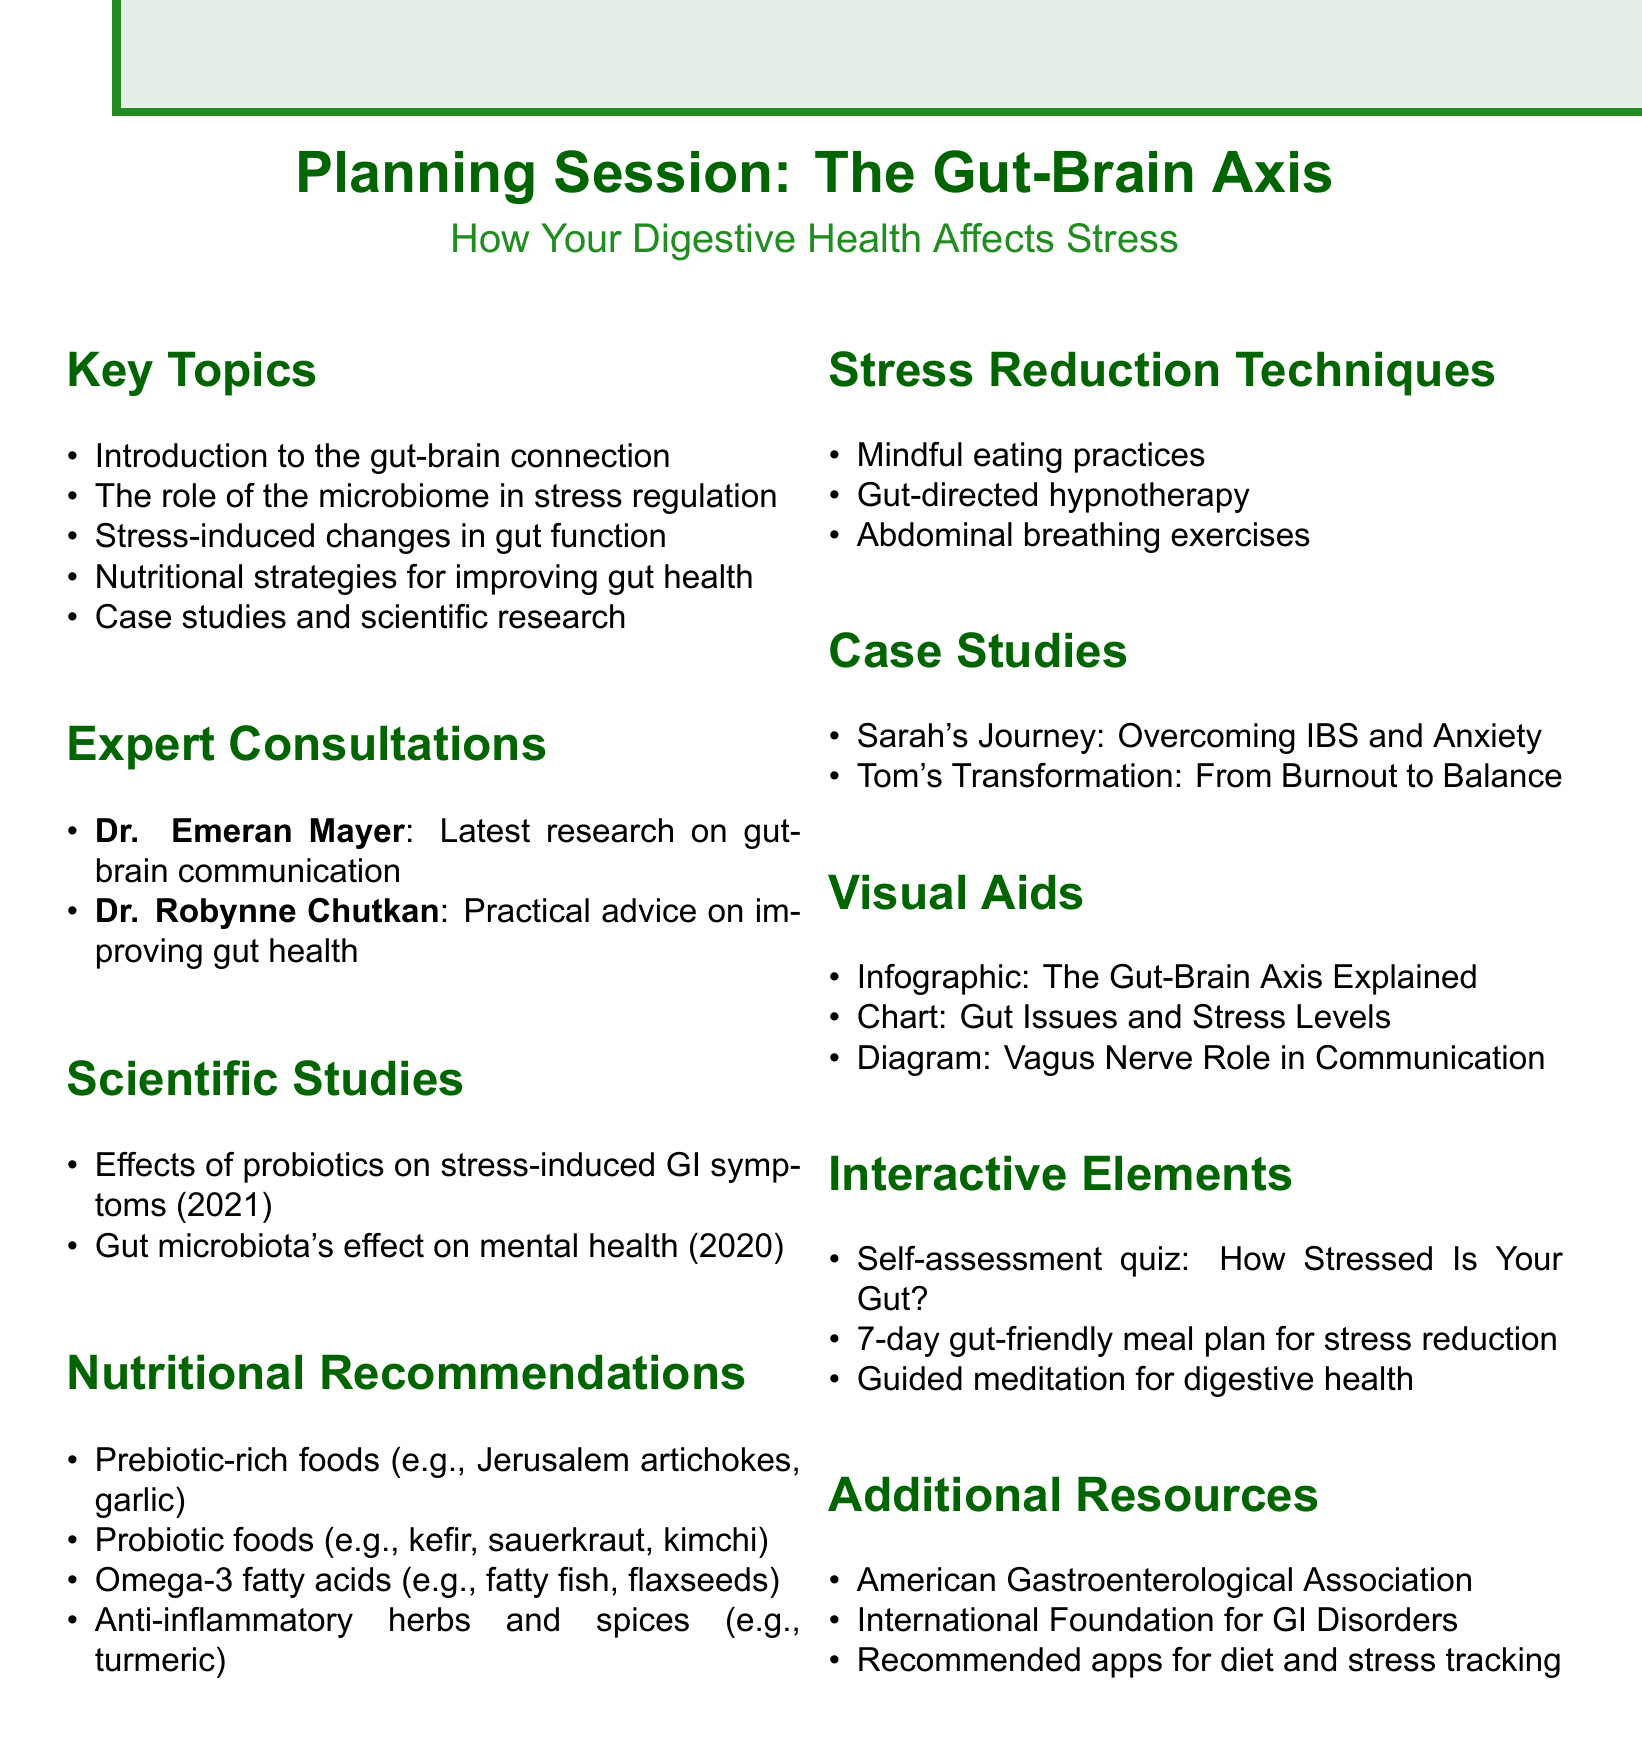What is the chapter title? The chapter title is explicitly mentioned at the beginning of the document under the title section.
Answer: The Gut-Brain Axis: How Your Digestive Health Affects Stress Who is the first expert consulted? The first expert listed in the expert consultations section is noted for their work in gastroenterology and a specific book.
Answer: Dr. Emeran Mayer What year was the study on probiotics published? The document lists the year of publication for each scientific study under the scientific studies section.
Answer: 2021 Name one nutrient recommended for improving gut health. Nutritional recommendations include specific foods or nutrients aimed at enhancing gut health.
Answer: Prebiotic-rich foods How many case studies are mentioned? The case studies section counts the unique personal experiences shared in the document.
Answer: 2 What technique is mentioned for stress reduction? Stress reduction techniques listed in the document highlight various approaches to manage stress.
Answer: Mindful eating practices What kind of visual aids are suggested? Visual aids are categorized in a dedicated section, aiming to explain complex concepts visually.
Answer: Infographic: The Gut-Brain Axis Explained What is one interactive element included in the chapter? The interactive elements section describes features that engage the reader actively with the content.
Answer: Self-assessment quiz: How Stressed Is Your Gut? What additional resource is provided? The additional resources section lists external organizations or materials related to gut health and stress management.
Answer: American Gastroenterological Association 